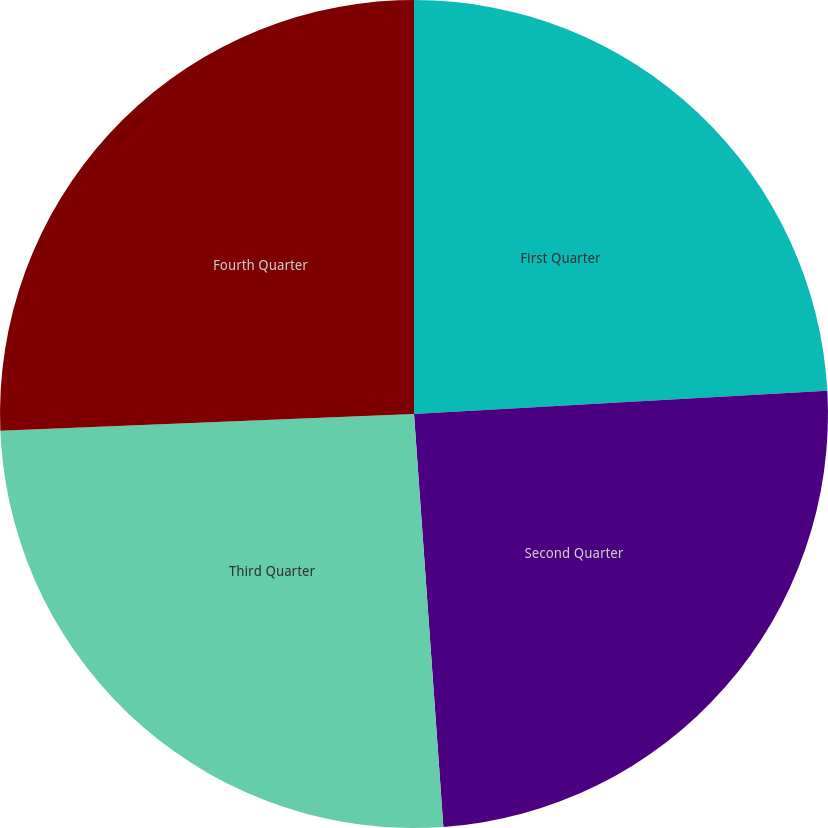Convert chart. <chart><loc_0><loc_0><loc_500><loc_500><pie_chart><fcel>First Quarter<fcel>Second Quarter<fcel>Third Quarter<fcel>Fourth Quarter<nl><fcel>24.11%<fcel>24.76%<fcel>25.49%<fcel>25.64%<nl></chart> 